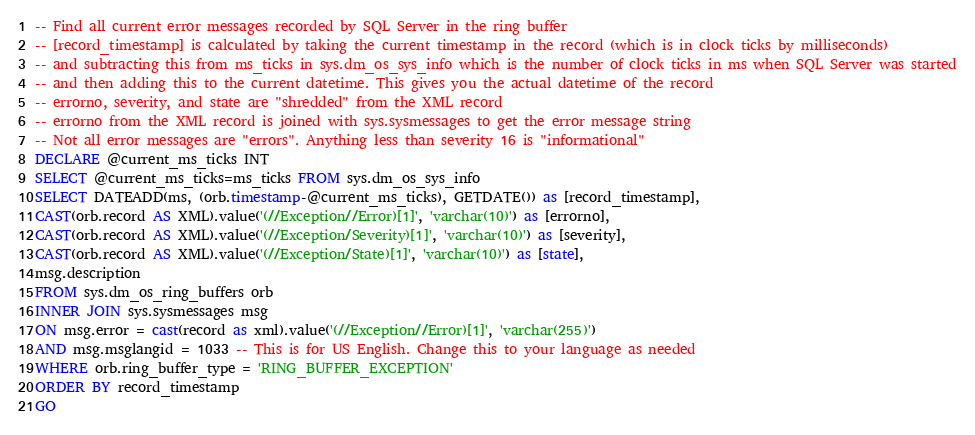<code> <loc_0><loc_0><loc_500><loc_500><_SQL_>-- Find all current error messages recorded by SQL Server in the ring buffer
-- [record_timestamp] is calculated by taking the current timestamp in the record (which is in clock ticks by milliseconds)
-- and subtracting this from ms_ticks in sys.dm_os_sys_info which is the number of clock ticks in ms when SQL Server was started
-- and then adding this to the current datetime. This gives you the actual datetime of the record
-- errorno, severity, and state are "shredded" from the XML record
-- errorno from the XML record is joined with sys.sysmessages to get the error message string
-- Not all error messages are "errors". Anything less than severity 16 is "informational"
DECLARE @current_ms_ticks INT
SELECT @current_ms_ticks=ms_ticks FROM sys.dm_os_sys_info
SELECT DATEADD(ms, (orb.timestamp-@current_ms_ticks), GETDATE()) as [record_timestamp],
CAST(orb.record AS XML).value('(//Exception//Error)[1]', 'varchar(10)') as [errorno],
CAST(orb.record AS XML).value('(//Exception/Severity)[1]', 'varchar(10)') as [severity],
CAST(orb.record AS XML).value('(//Exception/State)[1]', 'varchar(10)') as [state],
msg.description
FROM sys.dm_os_ring_buffers orb
INNER JOIN sys.sysmessages msg
ON msg.error = cast(record as xml).value('(//Exception//Error)[1]', 'varchar(255)')
AND msg.msglangid = 1033 -- This is for US English. Change this to your language as needed
WHERE orb.ring_buffer_type = 'RING_BUFFER_EXCEPTION'
ORDER BY record_timestamp
GO
</code> 